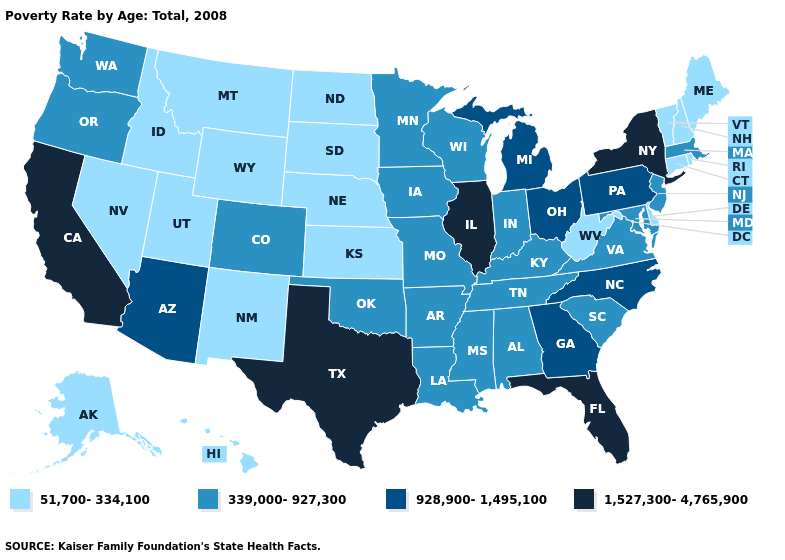What is the highest value in states that border Mississippi?
Short answer required. 339,000-927,300. Does Wisconsin have the lowest value in the USA?
Be succinct. No. Which states have the lowest value in the USA?
Be succinct. Alaska, Connecticut, Delaware, Hawaii, Idaho, Kansas, Maine, Montana, Nebraska, Nevada, New Hampshire, New Mexico, North Dakota, Rhode Island, South Dakota, Utah, Vermont, West Virginia, Wyoming. Does Utah have a higher value than South Dakota?
Give a very brief answer. No. Which states have the lowest value in the USA?
Answer briefly. Alaska, Connecticut, Delaware, Hawaii, Idaho, Kansas, Maine, Montana, Nebraska, Nevada, New Hampshire, New Mexico, North Dakota, Rhode Island, South Dakota, Utah, Vermont, West Virginia, Wyoming. Among the states that border Missouri , does Illinois have the highest value?
Give a very brief answer. Yes. What is the value of Tennessee?
Keep it brief. 339,000-927,300. Does Texas have the highest value in the USA?
Write a very short answer. Yes. What is the value of Montana?
Short answer required. 51,700-334,100. Does the map have missing data?
Concise answer only. No. Does the map have missing data?
Concise answer only. No. Does Delaware have the lowest value in the USA?
Quick response, please. Yes. What is the highest value in the USA?
Be succinct. 1,527,300-4,765,900. What is the highest value in the Northeast ?
Concise answer only. 1,527,300-4,765,900. What is the value of West Virginia?
Write a very short answer. 51,700-334,100. 